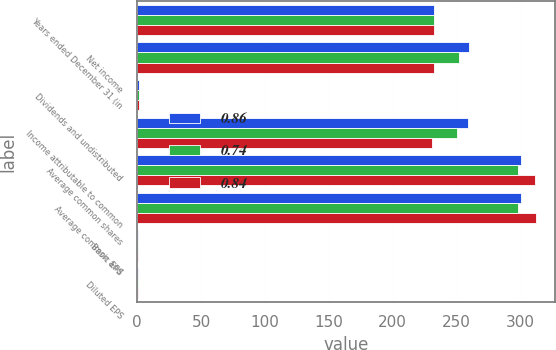Convert chart. <chart><loc_0><loc_0><loc_500><loc_500><stacked_bar_chart><ecel><fcel>Years ended December 31 (in<fcel>Net income<fcel>Dividends and undistributed<fcel>Income attributable to common<fcel>Average common shares<fcel>Average common and<fcel>Basic EPS<fcel>Diluted EPS<nl><fcel>0.86<fcel>232.4<fcel>260.1<fcel>1.1<fcel>259<fcel>300.4<fcel>300.4<fcel>0.86<fcel>0.86<nl><fcel>0.74<fcel>232.4<fcel>251.7<fcel>1.2<fcel>250.5<fcel>298.2<fcel>298.3<fcel>0.84<fcel>0.84<nl><fcel>0.84<fcel>232.4<fcel>232.4<fcel>1.2<fcel>231.2<fcel>311.9<fcel>312<fcel>0.74<fcel>0.74<nl></chart> 